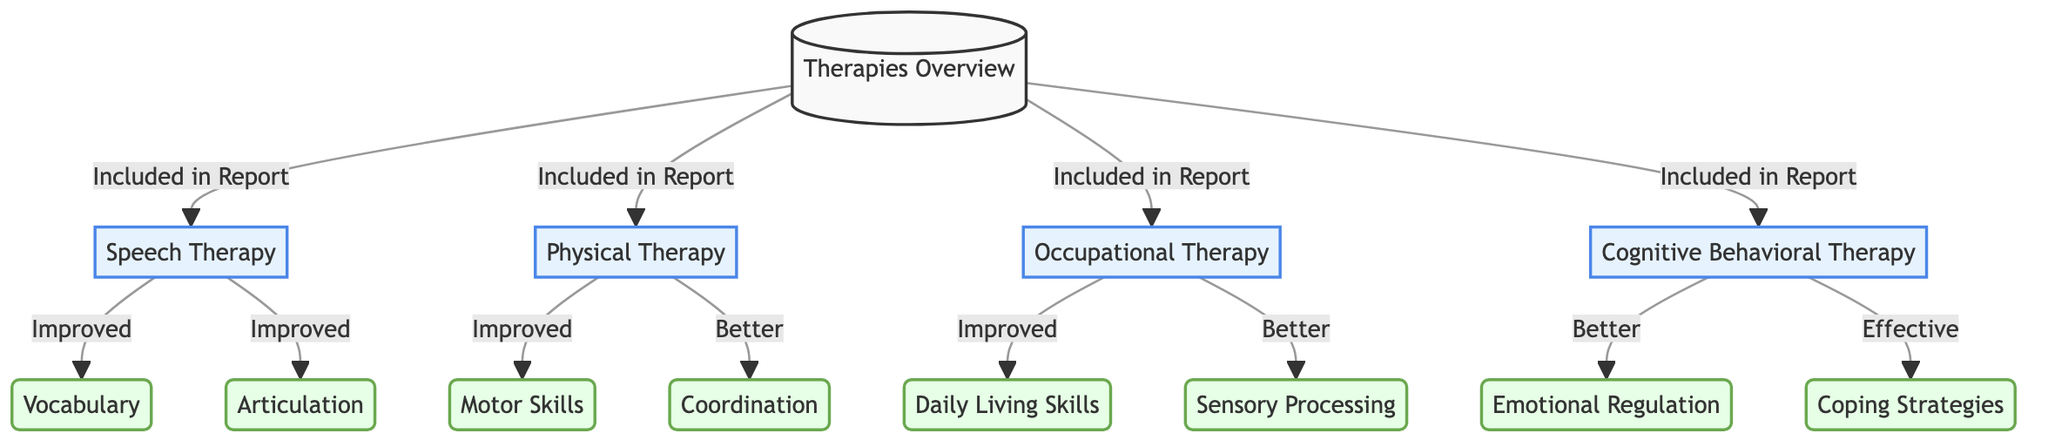What therapies are included in the report? The diagram lists four therapies connected to the "Therapies Overview" node: Speech Therapy, Physical Therapy, Occupational Therapy, and Cognitive Behavioral Therapy.
Answer: Speech Therapy, Physical Therapy, Occupational Therapy, Cognitive Behavioral Therapy How many skills show improvement in Occupational Therapy? Under the Occupational Therapy node, there are two skills listed as "Improved" and "Better": Daily Living Skills (improved) and Sensory Processing (better). This gives a total of two skills showing improvement.
Answer: 2 Which therapy shows improvement in Vocabulary? The "Vocabulary" node is directly connected to the "Speech Therapy" node, indicating that Speech Therapy is the therapy associated with the improvement in Vocabulary.
Answer: Speech Therapy What type of improvements are noted for Cognitive Behavioral Therapy? The Cognitive Behavioral Therapy node has two types of improvements listed: "Better" for Emotional Regulation and "Effective" for Coping Strategies. This indicates two different types of improvements.
Answer: Better, Effective Which skill improved in Physical Therapy? The diagram indicates that the skill "Motor Skills" improved under the Physical Therapy node, showing a direct connection.
Answer: Motor Skills What is the relationship between Speech Therapy and Articulation? The diagram shows that Articulation is linked to the Speech Therapy node, indicating that this therapy has had an improvement in Articulation.
Answer: Improved How many forms of improvement are associated with Physical Therapy? The Physical Therapy node has two forms of improvement connected: Motor Skills (improved) and Coordination (better). Thus, there are two improvements associated with Physical Therapy.
Answer: 2 